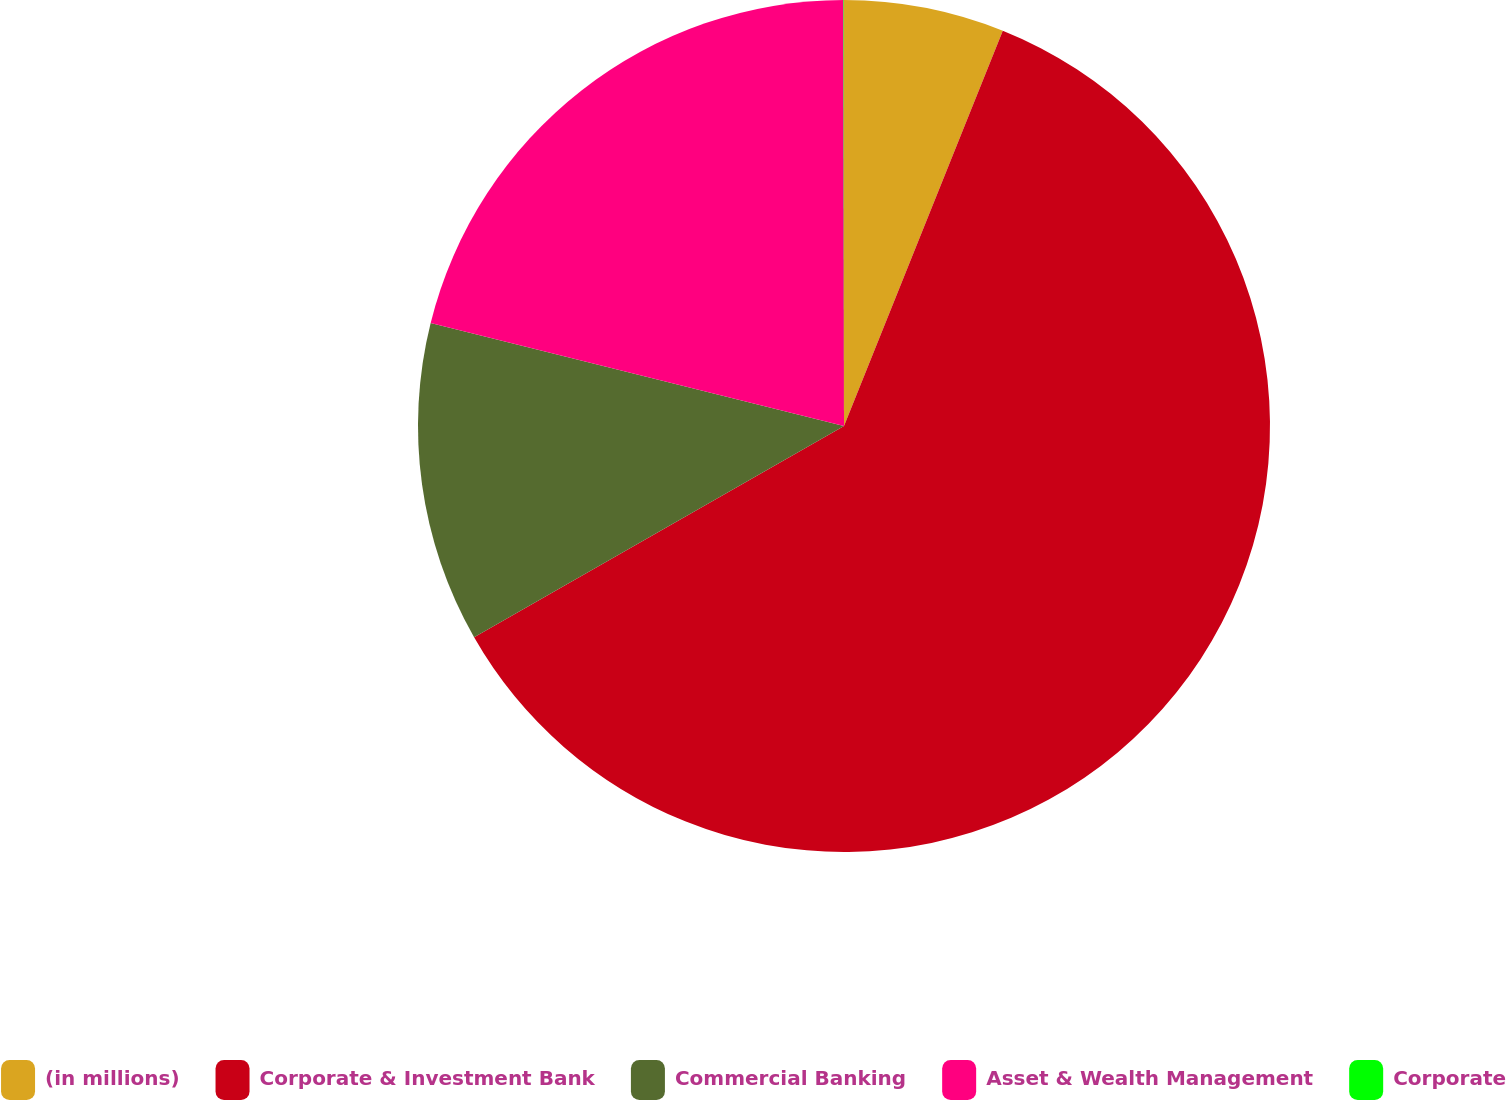Convert chart to OTSL. <chart><loc_0><loc_0><loc_500><loc_500><pie_chart><fcel>(in millions)<fcel>Corporate & Investment Bank<fcel>Commercial Banking<fcel>Asset & Wealth Management<fcel>Corporate<nl><fcel>6.08%<fcel>60.66%<fcel>12.15%<fcel>21.09%<fcel>0.02%<nl></chart> 